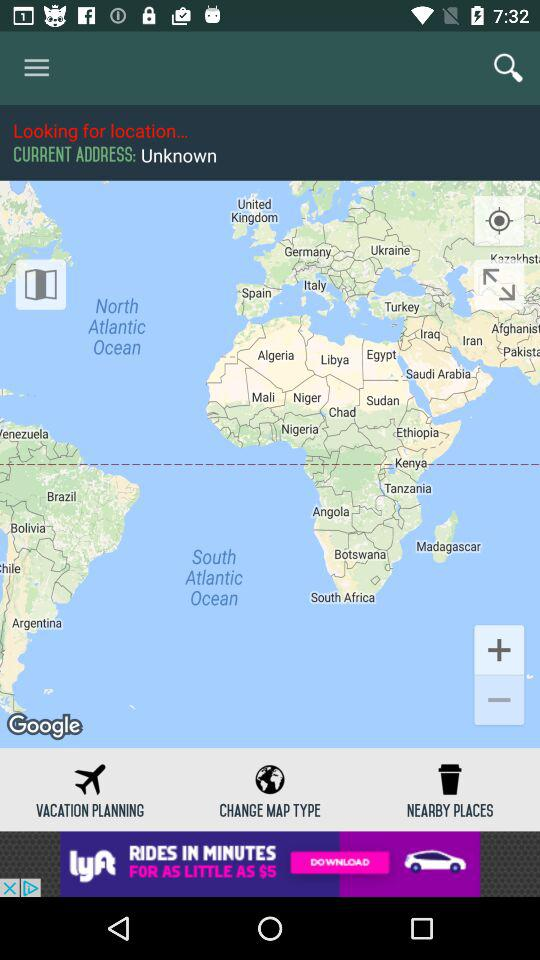What is the current address? The current address is unknown. 